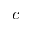<formula> <loc_0><loc_0><loc_500><loc_500>c</formula> 